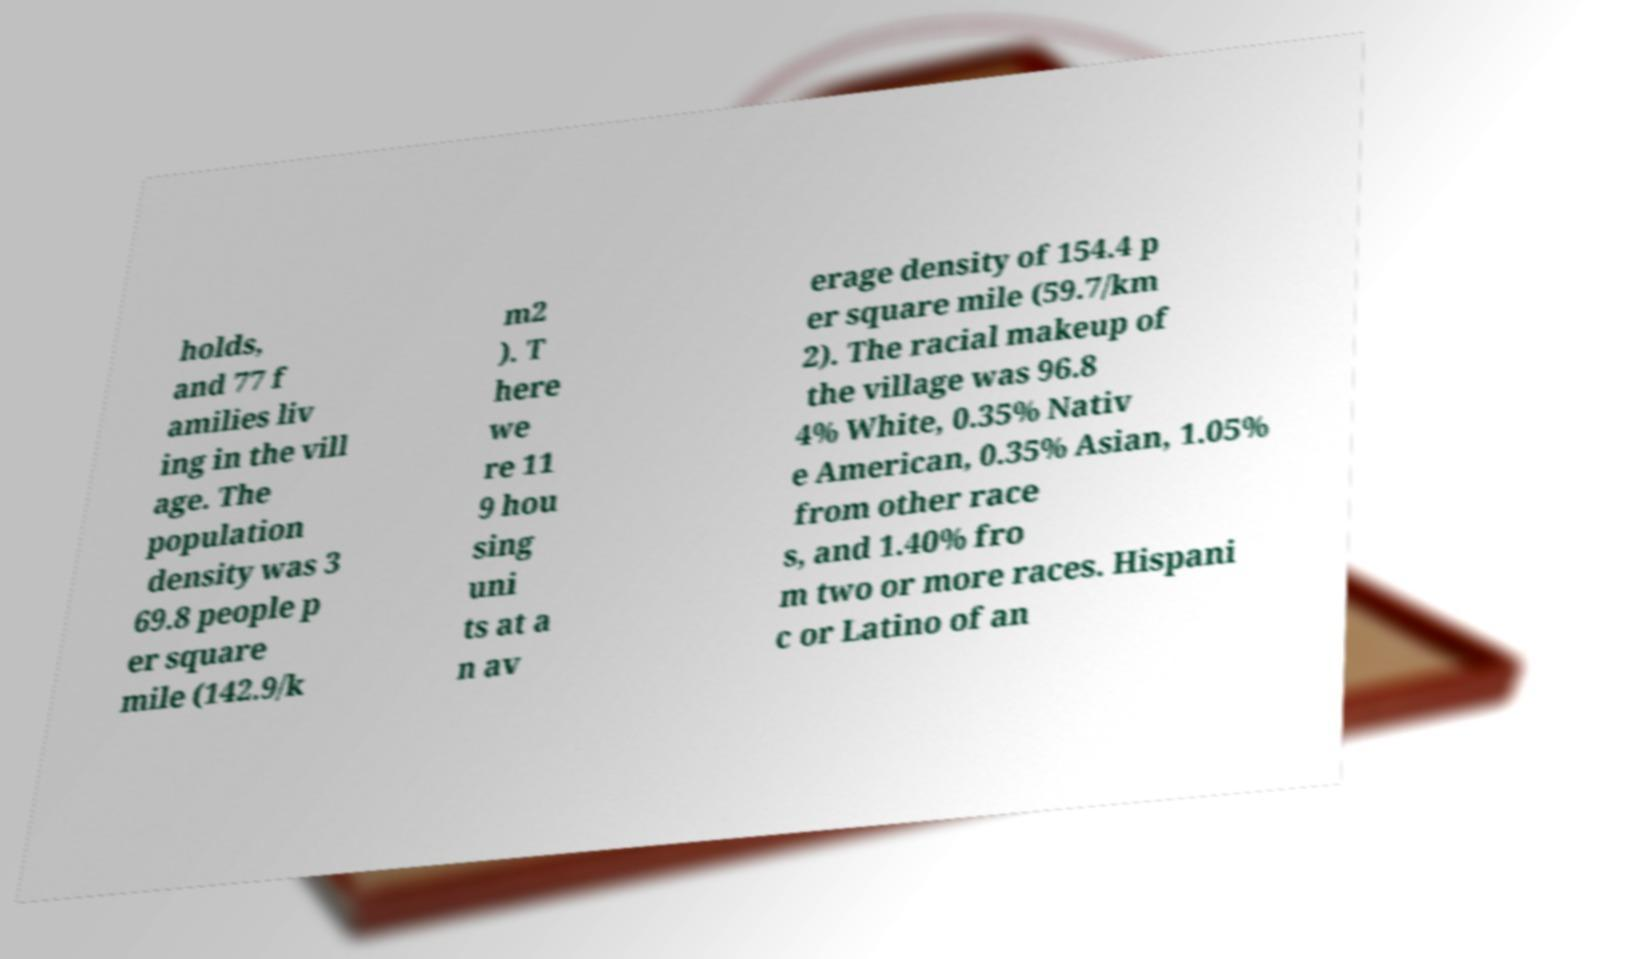For documentation purposes, I need the text within this image transcribed. Could you provide that? holds, and 77 f amilies liv ing in the vill age. The population density was 3 69.8 people p er square mile (142.9/k m2 ). T here we re 11 9 hou sing uni ts at a n av erage density of 154.4 p er square mile (59.7/km 2). The racial makeup of the village was 96.8 4% White, 0.35% Nativ e American, 0.35% Asian, 1.05% from other race s, and 1.40% fro m two or more races. Hispani c or Latino of an 